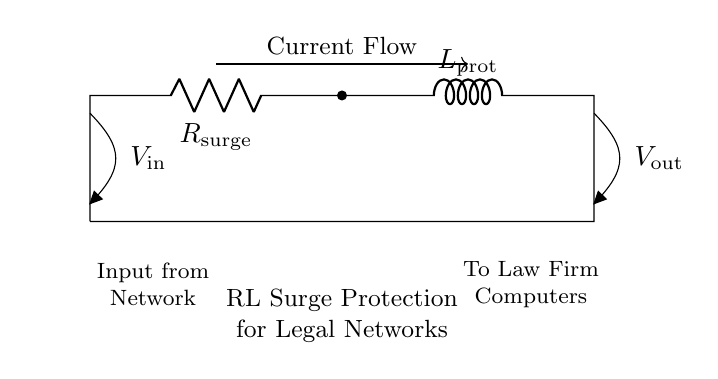What type of components are used in this circuit? The circuit includes a resistor and an inductor, which are the fundamental components of an RL circuit. The resistor is labeled as R and the inductor as L in the diagram.
Answer: Resistor and inductor What is the purpose of the resistor in this circuit? The resistor is used to limit the surge current entering the circuit, providing initial protection against voltage spikes. Its role is crucial for ensuring that the subsequent components are not damaged.
Answer: Limit surge current What happens to the current when a surge occurs? When a surge occurs, the inductor will oppose changes in current due to its property of inductance, resulting in a reduction of the surge current flowing through the circuit over time.
Answer: Reduces surge current What is indicated by the voltage labels in the circuit? The voltage labels V input and V output denote the potential difference at the input and output terminals of the circuit, illustrating how the surge protection works from the source to the connected devices.
Answer: V input and V output Describe the effect of inductance in surge protection. Inductance creates a magnetic field when current flows, which resists changes in current. In surge protection, this helps to smooth out abrupt increases in current, protecting sensitive computer equipment from damage.
Answer: Resists current changes 